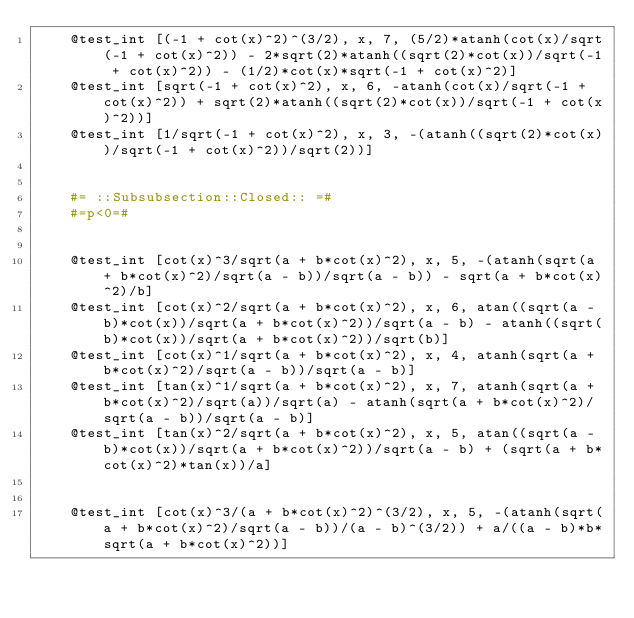Convert code to text. <code><loc_0><loc_0><loc_500><loc_500><_Julia_>    @test_int [(-1 + cot(x)^2)^(3/2), x, 7, (5/2)*atanh(cot(x)/sqrt(-1 + cot(x)^2)) - 2*sqrt(2)*atanh((sqrt(2)*cot(x))/sqrt(-1 + cot(x)^2)) - (1/2)*cot(x)*sqrt(-1 + cot(x)^2)]
    @test_int [sqrt(-1 + cot(x)^2), x, 6, -atanh(cot(x)/sqrt(-1 + cot(x)^2)) + sqrt(2)*atanh((sqrt(2)*cot(x))/sqrt(-1 + cot(x)^2))]
    @test_int [1/sqrt(-1 + cot(x)^2), x, 3, -(atanh((sqrt(2)*cot(x))/sqrt(-1 + cot(x)^2))/sqrt(2))]


    #= ::Subsubsection::Closed:: =#
    #=p<0=#


    @test_int [cot(x)^3/sqrt(a + b*cot(x)^2), x, 5, -(atanh(sqrt(a + b*cot(x)^2)/sqrt(a - b))/sqrt(a - b)) - sqrt(a + b*cot(x)^2)/b]
    @test_int [cot(x)^2/sqrt(a + b*cot(x)^2), x, 6, atan((sqrt(a - b)*cot(x))/sqrt(a + b*cot(x)^2))/sqrt(a - b) - atanh((sqrt(b)*cot(x))/sqrt(a + b*cot(x)^2))/sqrt(b)]
    @test_int [cot(x)^1/sqrt(a + b*cot(x)^2), x, 4, atanh(sqrt(a + b*cot(x)^2)/sqrt(a - b))/sqrt(a - b)]
    @test_int [tan(x)^1/sqrt(a + b*cot(x)^2), x, 7, atanh(sqrt(a + b*cot(x)^2)/sqrt(a))/sqrt(a) - atanh(sqrt(a + b*cot(x)^2)/sqrt(a - b))/sqrt(a - b)]
    @test_int [tan(x)^2/sqrt(a + b*cot(x)^2), x, 5, atan((sqrt(a - b)*cot(x))/sqrt(a + b*cot(x)^2))/sqrt(a - b) + (sqrt(a + b*cot(x)^2)*tan(x))/a]


    @test_int [cot(x)^3/(a + b*cot(x)^2)^(3/2), x, 5, -(atanh(sqrt(a + b*cot(x)^2)/sqrt(a - b))/(a - b)^(3/2)) + a/((a - b)*b*sqrt(a + b*cot(x)^2))]</code> 